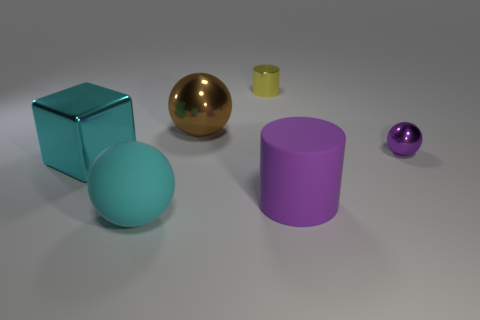Is the number of large brown shiny spheres right of the big purple matte cylinder the same as the number of small cyan metal cylinders?
Keep it short and to the point. Yes. There is a shiny sphere right of the big cylinder; is its color the same as the rubber thing behind the big matte ball?
Provide a short and direct response. Yes. How many things are both behind the cyan shiny cube and in front of the yellow metal cylinder?
Provide a short and direct response. 2. What number of other things are the same shape as the large cyan rubber object?
Offer a very short reply. 2. Are there more purple metal things that are right of the cyan metal cube than large purple cubes?
Your answer should be very brief. Yes. What is the color of the cylinder that is in front of the cyan metallic object?
Keep it short and to the point. Purple. The thing that is the same color as the small metallic ball is what size?
Provide a succinct answer. Large. How many rubber objects are either big spheres or tiny cylinders?
Offer a very short reply. 1. Is there a big shiny block in front of the tiny cylinder to the right of the cyan cube that is in front of the small cylinder?
Make the answer very short. Yes. What number of big metallic spheres are to the left of the purple metal object?
Provide a short and direct response. 1. 